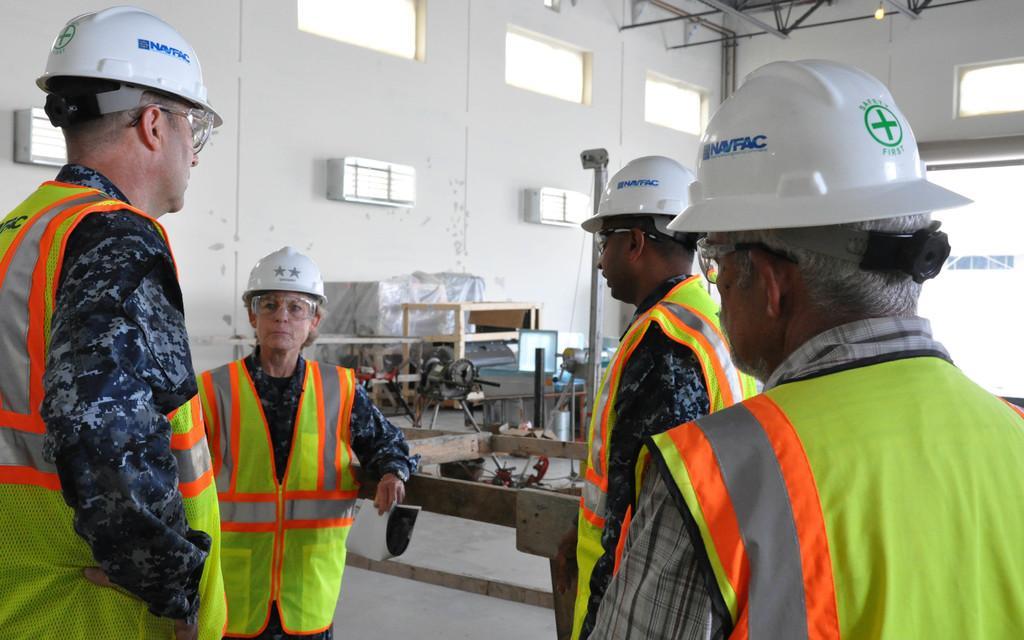How would you summarize this image in a sentence or two? In this image we can see a group of people wearing dress, helmets and goggles is standing on the ground. In the background, we can see a some wood pieces, machine and some boxes placed on the ground, a group of windows on a wall, some lights, poles and a door. 